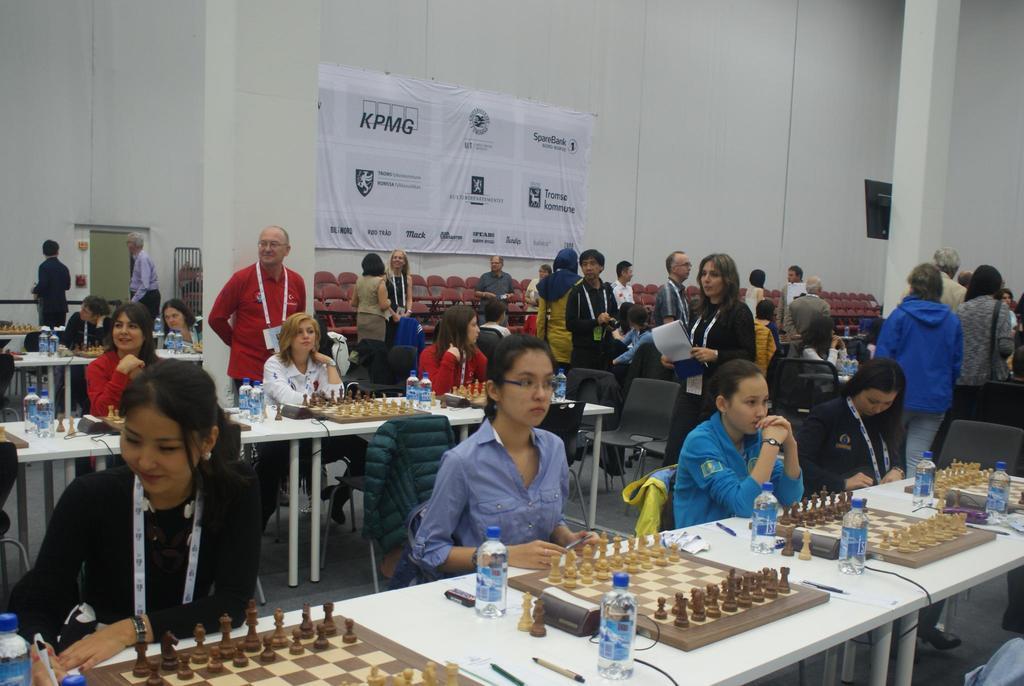Please provide a concise description of this image. There are few people sitting on the chairs. These are the tables with water bottles,chess board,chess coins,pens and few other things on it. I can see few people standing. This is the pillar which is white in color. I can see a banner attached to the wall. These are the empty chairs. I think this is the screen attached to the pillar. 